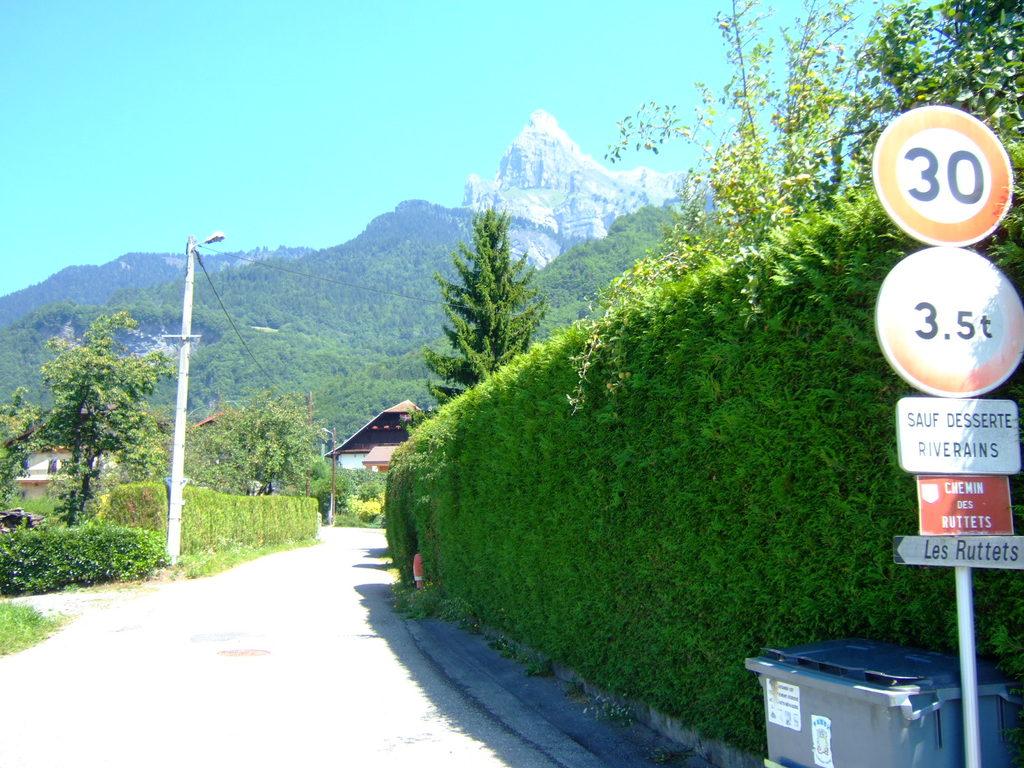What number is at the top of the sign?
Your answer should be compact. 30. What is displayed in the topmost sign  post?
Your answer should be compact. 30. 